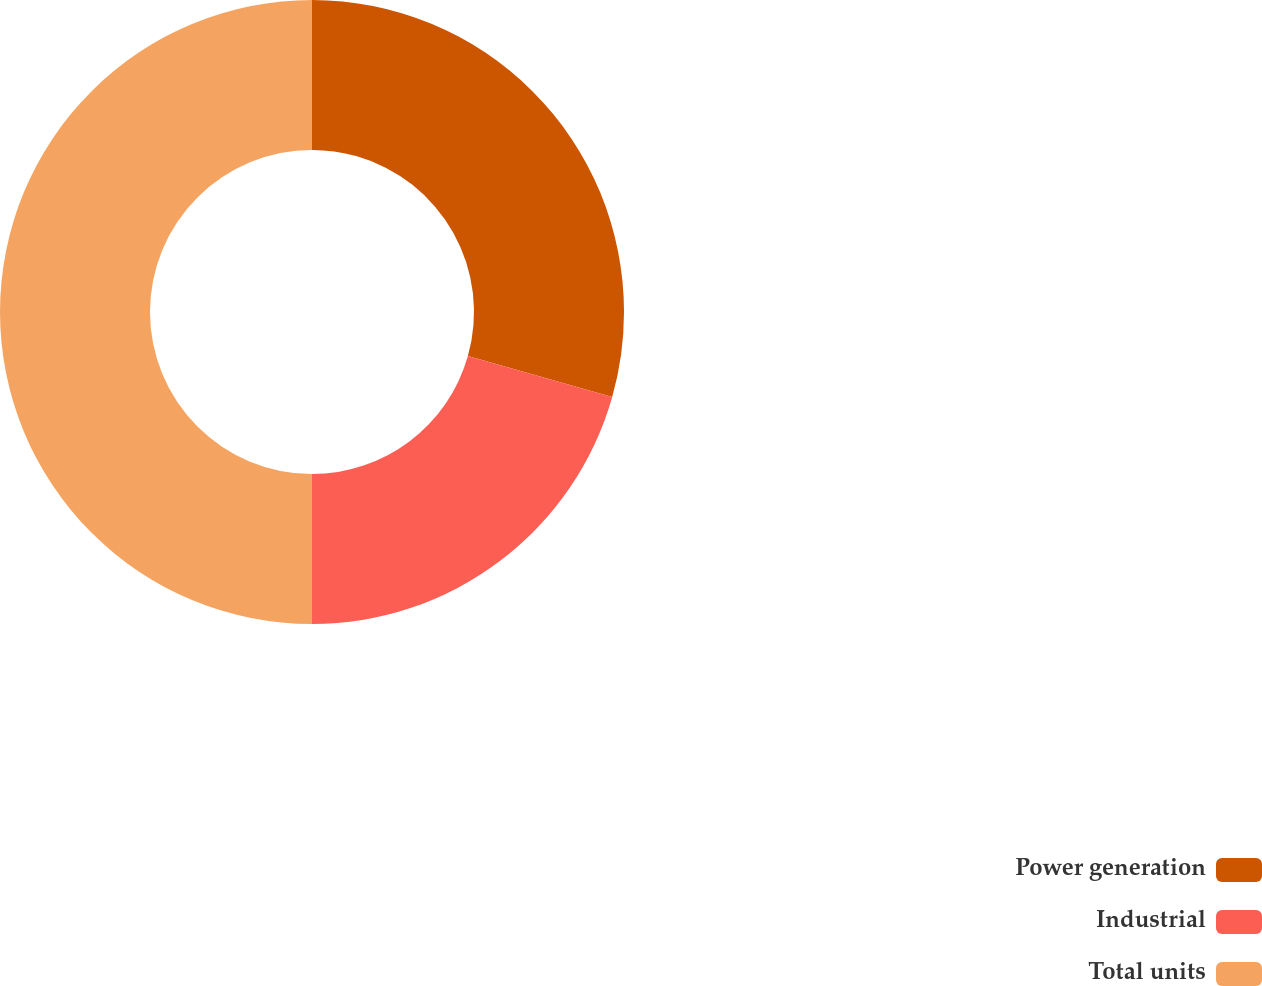Convert chart. <chart><loc_0><loc_0><loc_500><loc_500><pie_chart><fcel>Power generation<fcel>Industrial<fcel>Total units<nl><fcel>29.39%<fcel>20.61%<fcel>50.0%<nl></chart> 